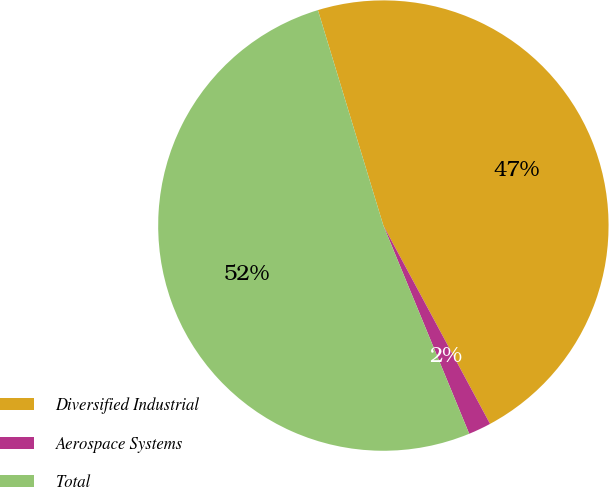<chart> <loc_0><loc_0><loc_500><loc_500><pie_chart><fcel>Diversified Industrial<fcel>Aerospace Systems<fcel>Total<nl><fcel>46.84%<fcel>1.63%<fcel>51.53%<nl></chart> 